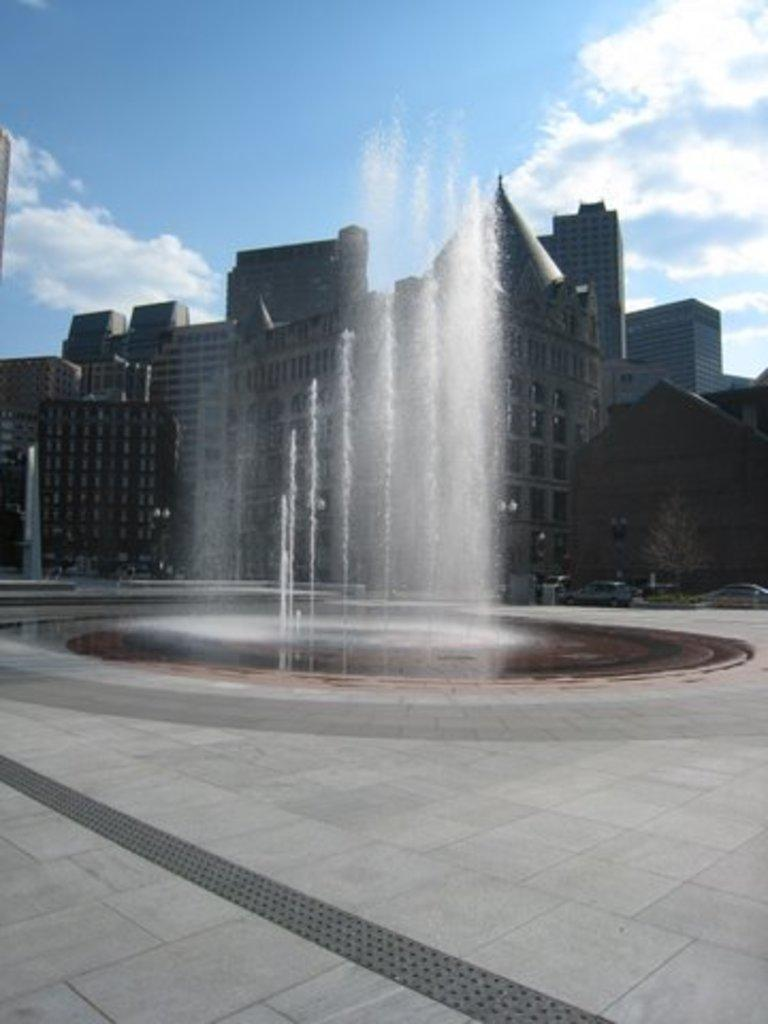What type of structure is visible in the image? There is a building in the image. What is another feature that can be seen in the image? There is a water fountain in the image. What else is present in the image besides the building and water fountain? Vehicles and trees are present in the image. What can be seen in the background of the image? The sky is visible in the background of the image. What song is being sung by the trees in the image? There is no indication in the image that the trees are singing a song, as trees do not have the ability to sing. What color are the eyes of the water fountain in the image? The water fountain does not have eyes, as it is an inanimate object. 